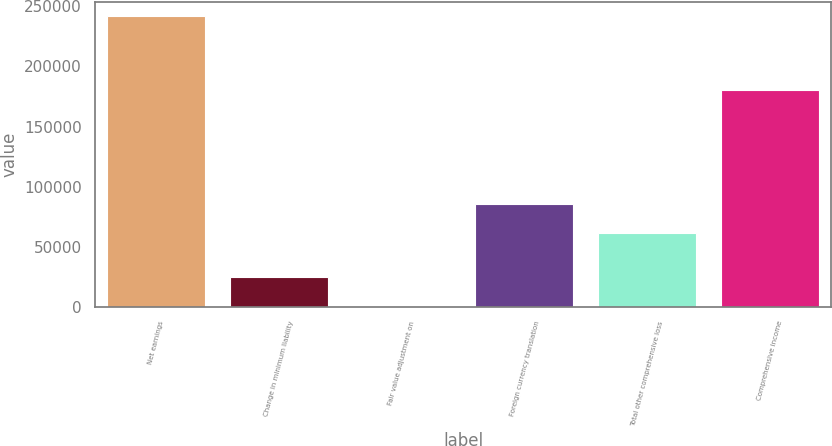<chart> <loc_0><loc_0><loc_500><loc_500><bar_chart><fcel>Net earnings<fcel>Change in minimum liability<fcel>Fair value adjustment on<fcel>Foreign currency translation<fcel>Total other comprehensive loss<fcel>Comprehensive income<nl><fcel>241686<fcel>24710.4<fcel>602<fcel>85825.4<fcel>61717<fcel>179969<nl></chart> 